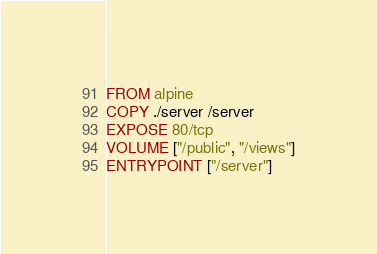Convert code to text. <code><loc_0><loc_0><loc_500><loc_500><_Dockerfile_>FROM alpine
COPY ./server /server
EXPOSE 80/tcp
VOLUME ["/public", "/views"]
ENTRYPOINT ["/server"]</code> 